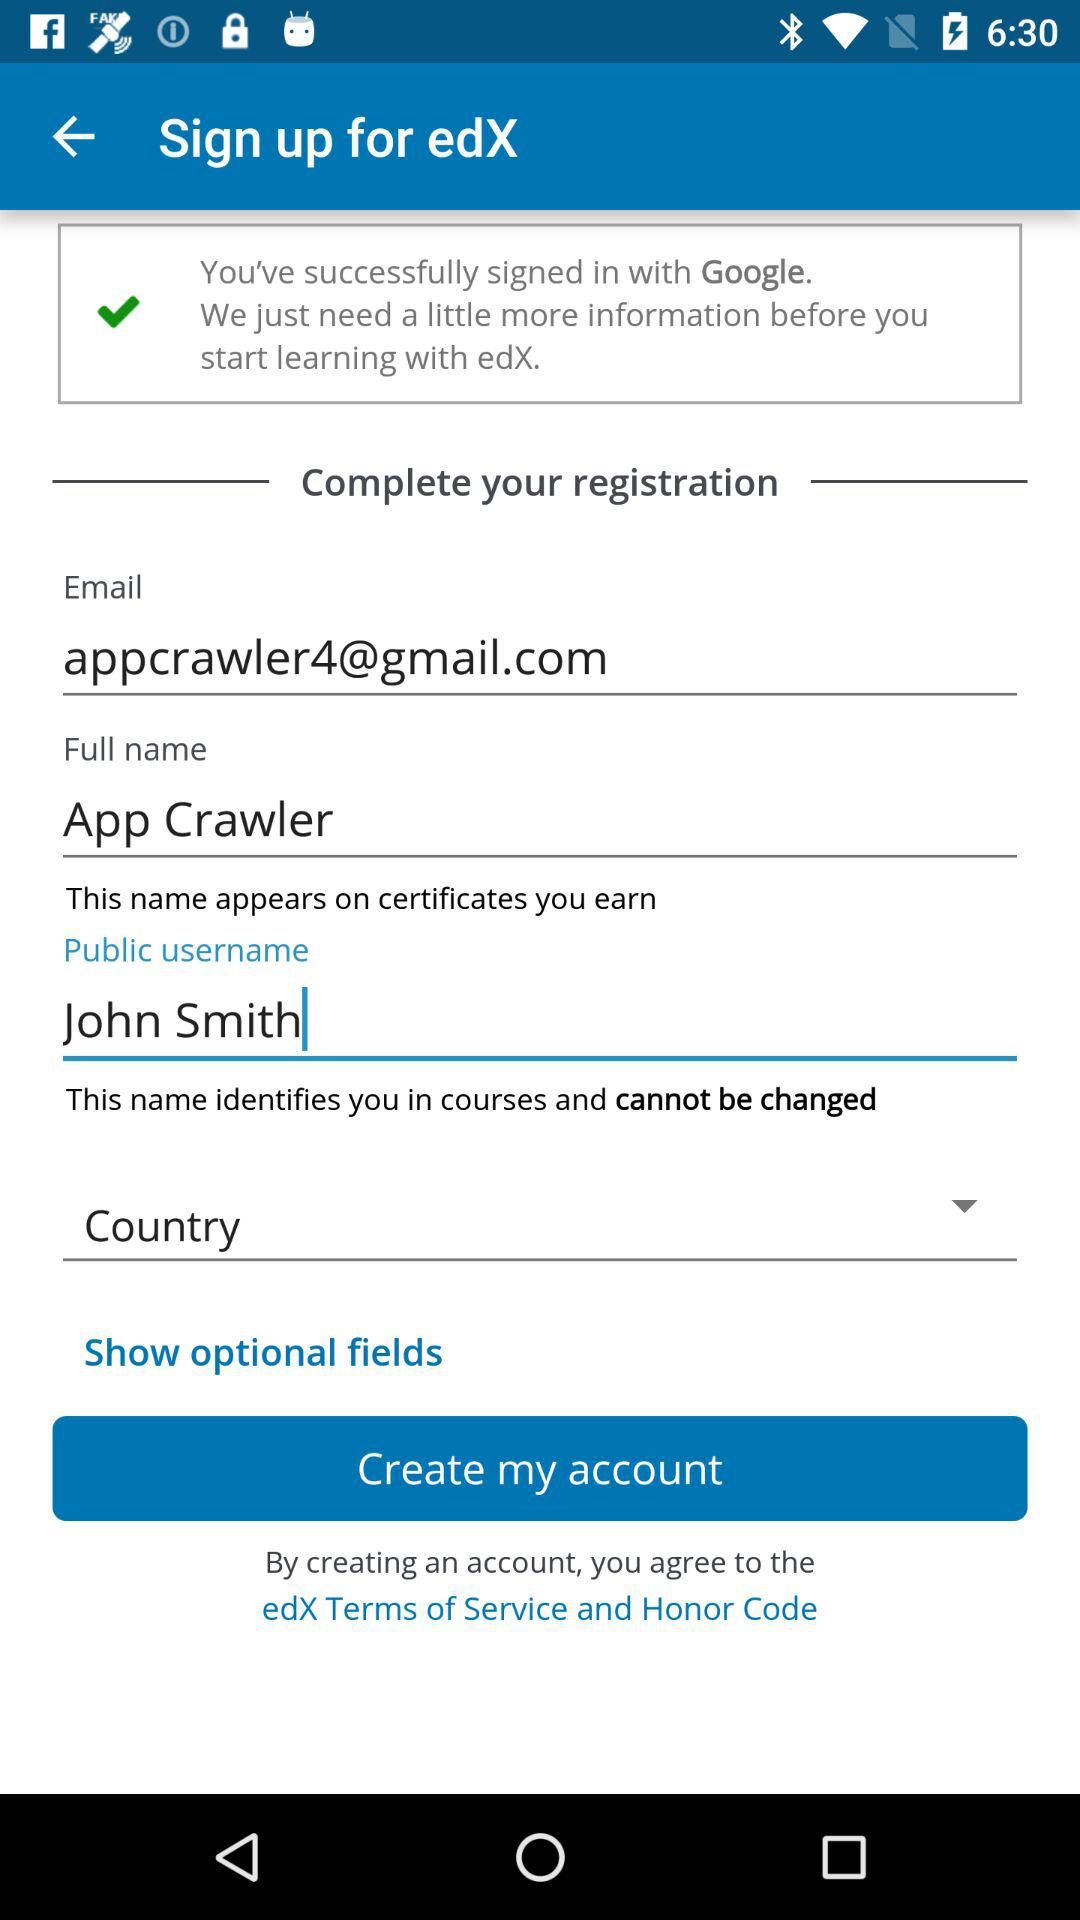How many text inputs have the default value 'John Smith'?
Answer the question using a single word or phrase. 1 